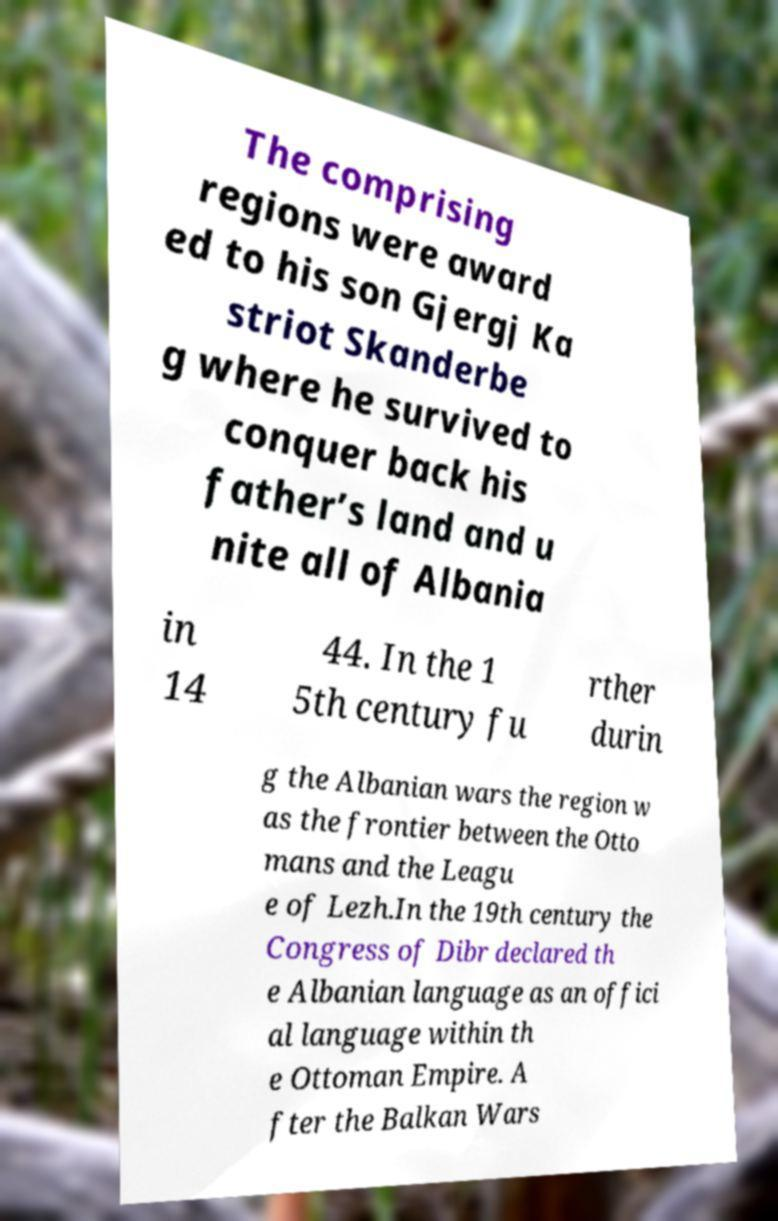Please read and relay the text visible in this image. What does it say? The comprising regions were award ed to his son Gjergj Ka striot Skanderbe g where he survived to conquer back his father’s land and u nite all of Albania in 14 44. In the 1 5th century fu rther durin g the Albanian wars the region w as the frontier between the Otto mans and the Leagu e of Lezh.In the 19th century the Congress of Dibr declared th e Albanian language as an offici al language within th e Ottoman Empire. A fter the Balkan Wars 